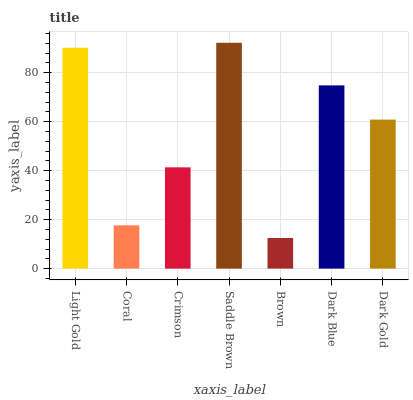Is Brown the minimum?
Answer yes or no. Yes. Is Saddle Brown the maximum?
Answer yes or no. Yes. Is Coral the minimum?
Answer yes or no. No. Is Coral the maximum?
Answer yes or no. No. Is Light Gold greater than Coral?
Answer yes or no. Yes. Is Coral less than Light Gold?
Answer yes or no. Yes. Is Coral greater than Light Gold?
Answer yes or no. No. Is Light Gold less than Coral?
Answer yes or no. No. Is Dark Gold the high median?
Answer yes or no. Yes. Is Dark Gold the low median?
Answer yes or no. Yes. Is Crimson the high median?
Answer yes or no. No. Is Crimson the low median?
Answer yes or no. No. 